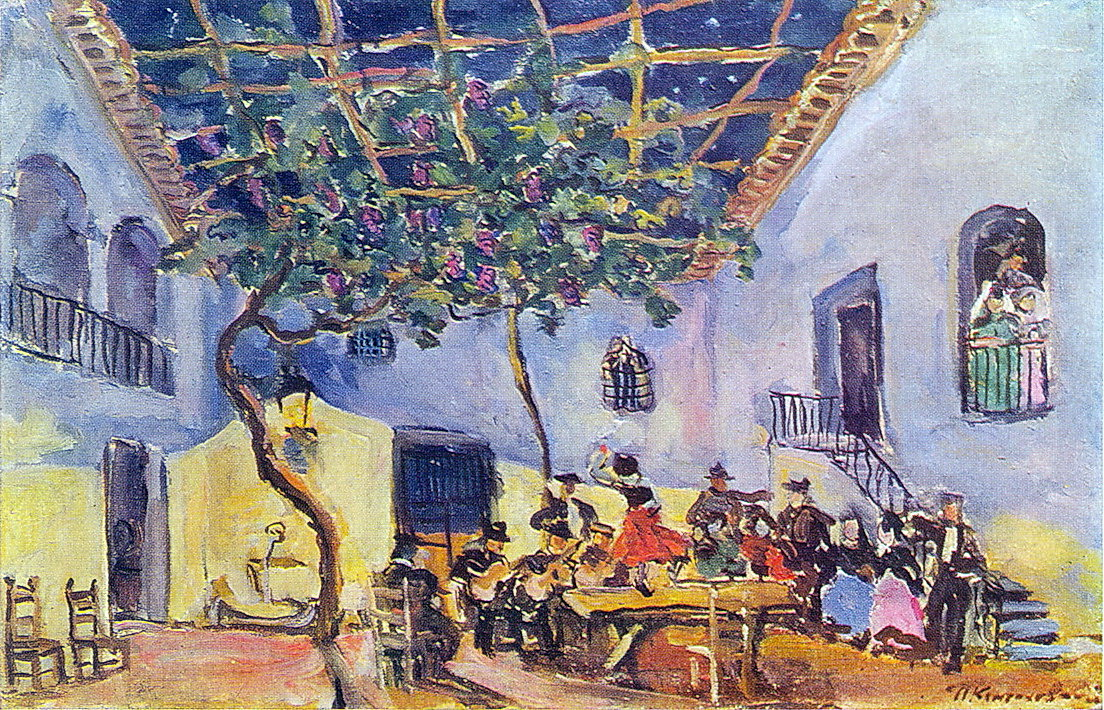What might the people in the painting be celebrating? The people in the painting could be celebrating a variety of joyous occasions, such as a wedding, a local festival, or a family reunion. The lively atmosphere, the gathering of friends and family, and the colorful clothing suggest a special event where music, dance, and socializing are central. The impressionist style captures the essence of their happiness and camaraderie, making it a scene filled with celebration and shared joy.  Imagine an artist who saw this scene and was inspired to paint it. What might they have been thinking or feeling? An artist observing this lively scene might have been captivated by the vibrant interplay of colors, the joyful energy of the people, and the enchanting atmosphere of the courtyard. They might have felt a deep sense of nostalgia and warmth, wanting to capture the fleeting beauty of the moment. The artist's thoughts could have been filled with the desire to immortalize the happiness, the communal spirit, and the harmony between nature and human activity. Inspired by the vivid hues and the dynamic composition, the artist would translate their emotional response onto the canvas, using impressionist techniques to convey the movement, energy, and life of the scene.  In what ways might the painting evoke a sense of nostalgia for viewers? The painting might evoke a sense of nostalgia for viewers through its depiction of simple yet profound moments of joy and togetherness. The impressionist style, with its loose brushstrokes and vibrant colors, captures the essence of fleeting moments rather than detailed realism, allowing viewers to project their own memories and emotions onto the scene. The idyllic setting, with the lush greenery, clear sky, and traditional architecture, might remind viewers of cherished times spent with loved ones in similar outdoor gatherings. The painting's ability to convey a timeless and universal sense of community, celebration, and connection to nature can stir feelings of longing for past experiences and the joy of shared human moments. 